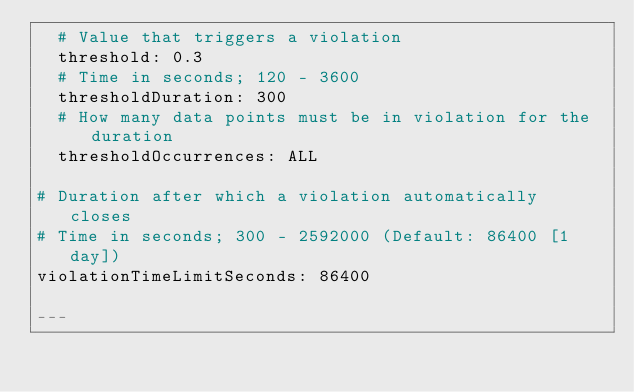Convert code to text. <code><loc_0><loc_0><loc_500><loc_500><_YAML_>  # Value that triggers a violation
  threshold: 0.3
  # Time in seconds; 120 - 3600
  thresholdDuration: 300
  # How many data points must be in violation for the duration
  thresholdOccurrences: ALL

# Duration after which a violation automatically closes
# Time in seconds; 300 - 2592000 (Default: 86400 [1 day])
violationTimeLimitSeconds: 86400

---</code> 